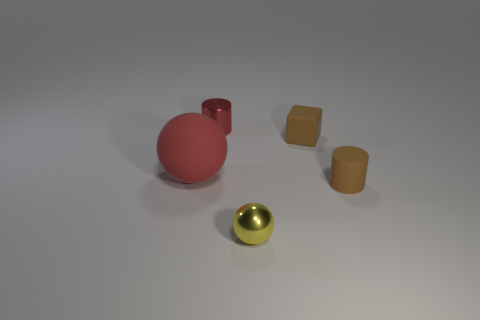Add 2 large green rubber things. How many objects exist? 7 Subtract all yellow balls. How many balls are left? 1 Subtract all cylinders. How many objects are left? 3 Subtract 1 cylinders. How many cylinders are left? 1 Subtract all yellow spheres. Subtract all cyan cubes. How many spheres are left? 1 Subtract all yellow cylinders. How many purple cubes are left? 0 Subtract all small brown matte cylinders. Subtract all metal objects. How many objects are left? 2 Add 3 small matte cylinders. How many small matte cylinders are left? 4 Add 3 yellow rubber cubes. How many yellow rubber cubes exist? 3 Subtract 1 yellow spheres. How many objects are left? 4 